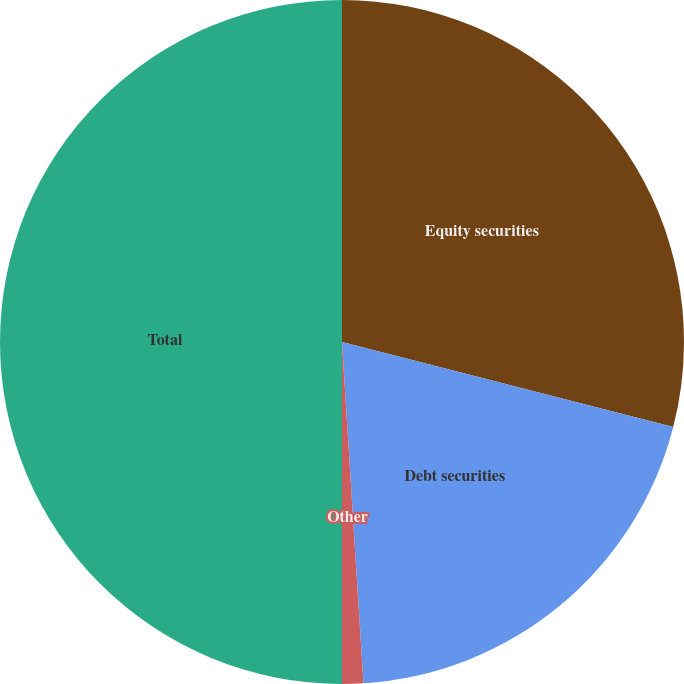<chart> <loc_0><loc_0><loc_500><loc_500><pie_chart><fcel>Equity securities<fcel>Debt securities<fcel>Other<fcel>Total<nl><fcel>29.0%<fcel>20.0%<fcel>1.0%<fcel>50.0%<nl></chart> 